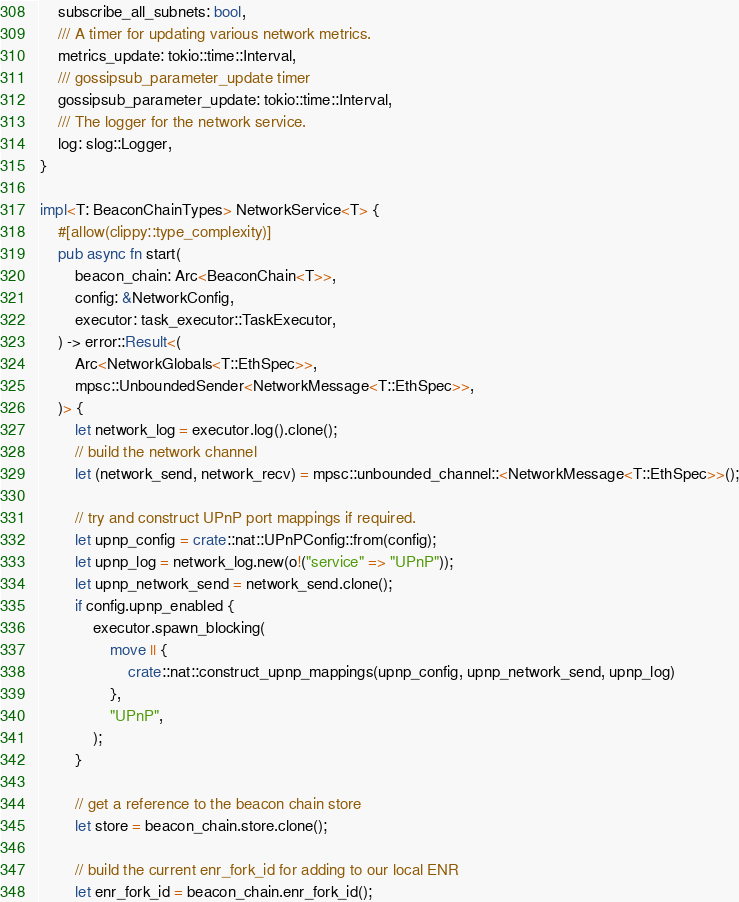<code> <loc_0><loc_0><loc_500><loc_500><_Rust_>    subscribe_all_subnets: bool,
    /// A timer for updating various network metrics.
    metrics_update: tokio::time::Interval,
    /// gossipsub_parameter_update timer
    gossipsub_parameter_update: tokio::time::Interval,
    /// The logger for the network service.
    log: slog::Logger,
}

impl<T: BeaconChainTypes> NetworkService<T> {
    #[allow(clippy::type_complexity)]
    pub async fn start(
        beacon_chain: Arc<BeaconChain<T>>,
        config: &NetworkConfig,
        executor: task_executor::TaskExecutor,
    ) -> error::Result<(
        Arc<NetworkGlobals<T::EthSpec>>,
        mpsc::UnboundedSender<NetworkMessage<T::EthSpec>>,
    )> {
        let network_log = executor.log().clone();
        // build the network channel
        let (network_send, network_recv) = mpsc::unbounded_channel::<NetworkMessage<T::EthSpec>>();

        // try and construct UPnP port mappings if required.
        let upnp_config = crate::nat::UPnPConfig::from(config);
        let upnp_log = network_log.new(o!("service" => "UPnP"));
        let upnp_network_send = network_send.clone();
        if config.upnp_enabled {
            executor.spawn_blocking(
                move || {
                    crate::nat::construct_upnp_mappings(upnp_config, upnp_network_send, upnp_log)
                },
                "UPnP",
            );
        }

        // get a reference to the beacon chain store
        let store = beacon_chain.store.clone();

        // build the current enr_fork_id for adding to our local ENR
        let enr_fork_id = beacon_chain.enr_fork_id();
</code> 